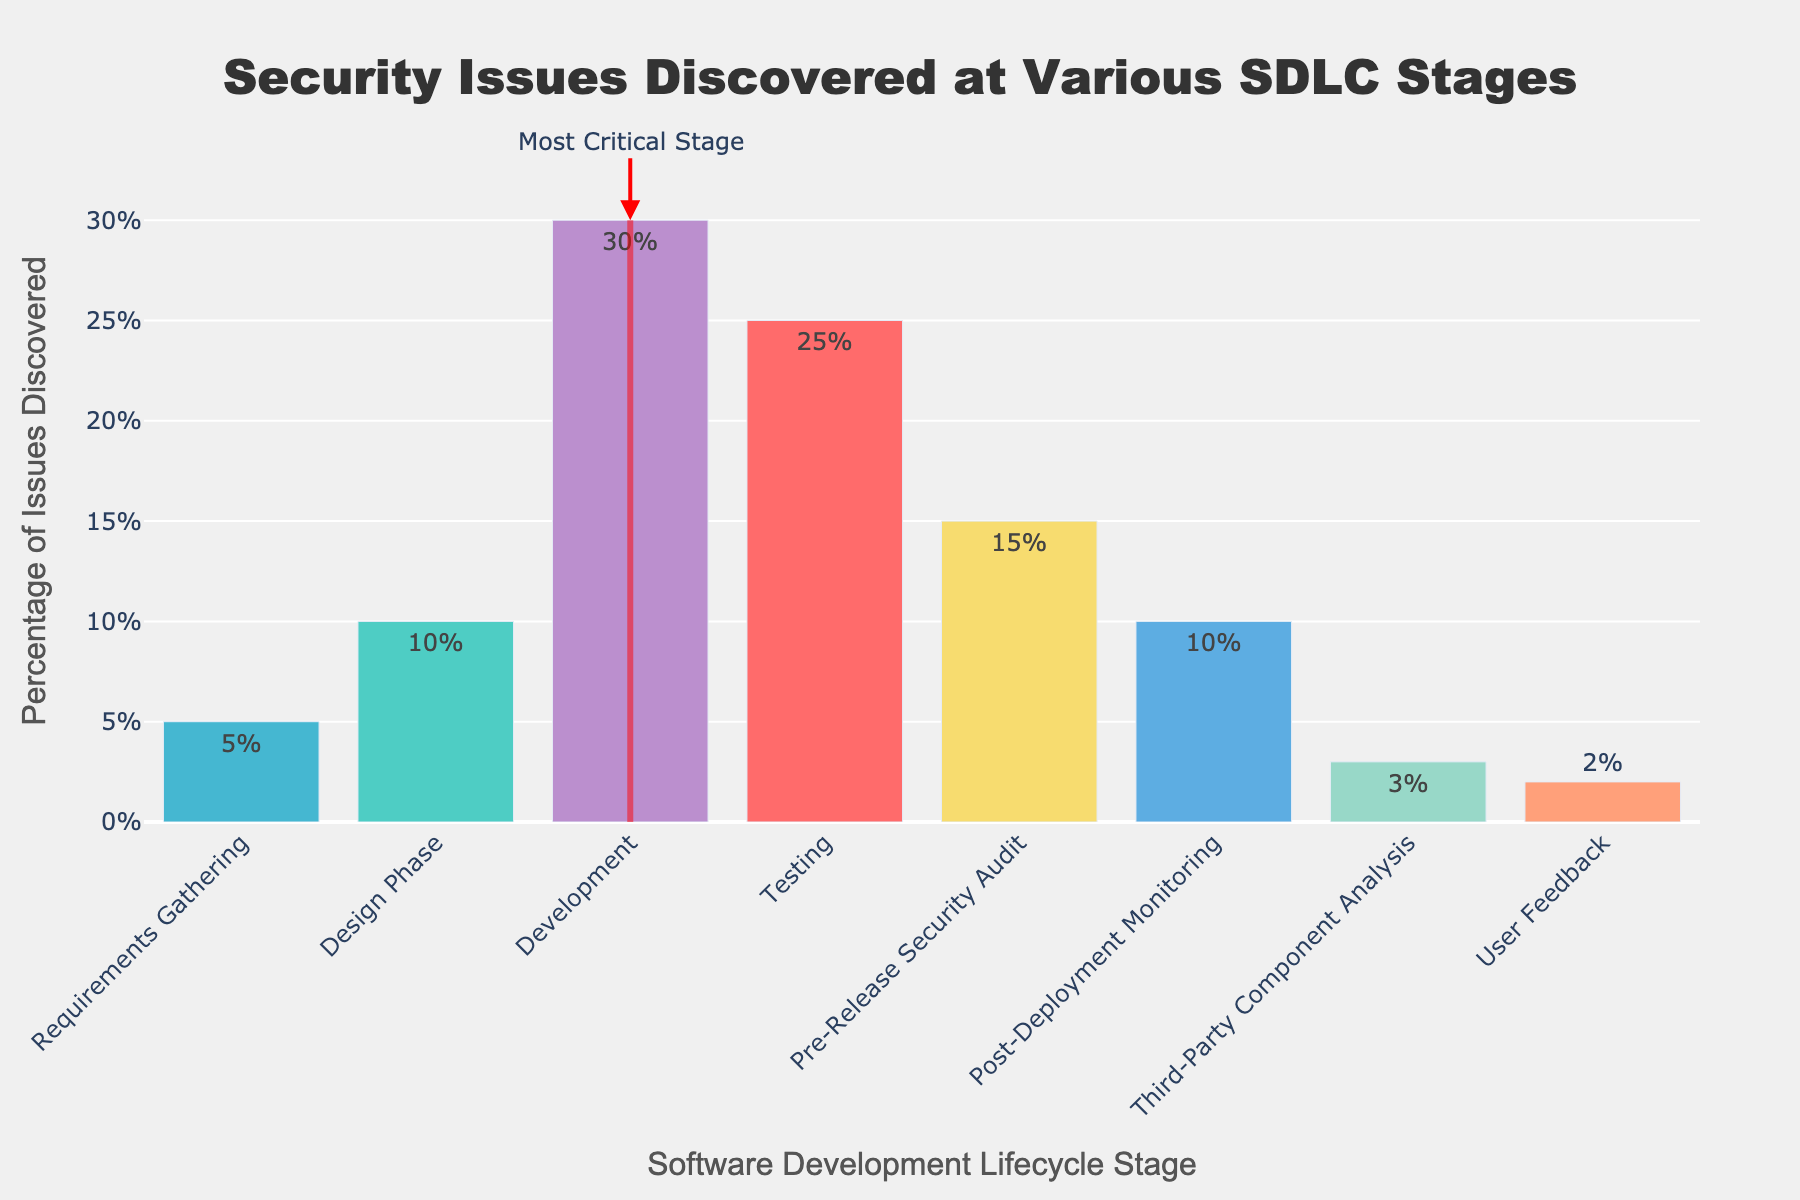Which stage has the highest percentage of security issues discovered? The bar chart indicates the highest percentage of security issues discovered in the 'Development' stage. This is denoted by the tallest bar.
Answer: Development What's the difference in the percentage of issues discovered between the 'Testing' phase and 'Pre-Release Security Audit'? Subtract the percentage for 'Pre-Release Security Audit' from the percentage for 'Testing'. This gives 25% - 15% = 10%.
Answer: 10% Compare the percentages of security issues discovered in 'Requirements Gathering' and 'Design Phase'. Which stage has more issues and by how much? The 'Design Phase' has 10% and 'Requirements Gathering' has 5%. The difference is 10% - 5% = 5%. Thus, 'Design Phase' has 5% more issues.
Answer: Design Phase, 5% How does the percentage of issues found in 'Pre-Release Security Audit' compare to 'Post-Deployment Monitoring'? The bar chart shows that 'Pre-Release Security Audit' has 15% and 'Post-Deployment Monitoring' has 10%. Therefore, 'Pre-Release Security Audit' has 5% more issues.
Answer: Pre-Release Security Audit, 5% What is the combined percentage of security issues discovered during 'User Feedback' and 'Third-Party Component Analysis'? Add the percentages for 'User Feedback' and 'Third-Party Component Analysis'. This gives 2% + 3% = 5%.
Answer: 5% Which stage has fewer security issues discovered than 'Post-Deployment Monitoring'? Comparing the heights of the bars, both 'Third-Party Component Analysis' (3%) and 'User Feedback' (2%) have fewer issues than 'Post-Deployment Monitoring' (10%).
Answer: Third-Party Component Analysis and User Feedback What is the range of percentages for security issues discovered across all stages? The minimum value is 2% (User Feedback) and the maximum value is 30% (Development). The range is 30% - 2% = 28%.
Answer: 28% Are there any stages with the same percentage of security issues discovered? No two bars have the same height, indicating that all stages have unique percentages of security issues discovered.
Answer: No Identify the stage with the least percentage of security issues and highlight its percentage difference from the stage with the highest percentage of issues. 'User Feedback' has the least percentage (2%) and 'Development' has the highest (30%). The difference is 30% - 2% = 28%.
Answer: User Feedback, 28% How do the percentages of security issues discovered in 'Development' and 'Testing' stages compare with all other stages combined? Sum the percentages for 'Development' (30%) and 'Testing' (25%) to get 55%. Sum the percentages for all other stages: 5% + 10% + 15% + 10% + 3% + 2% = 45% combined. 'Development' and 'Testing' have a higher combined percentage (55% vs. 45%).
Answer: 55%, 45% 